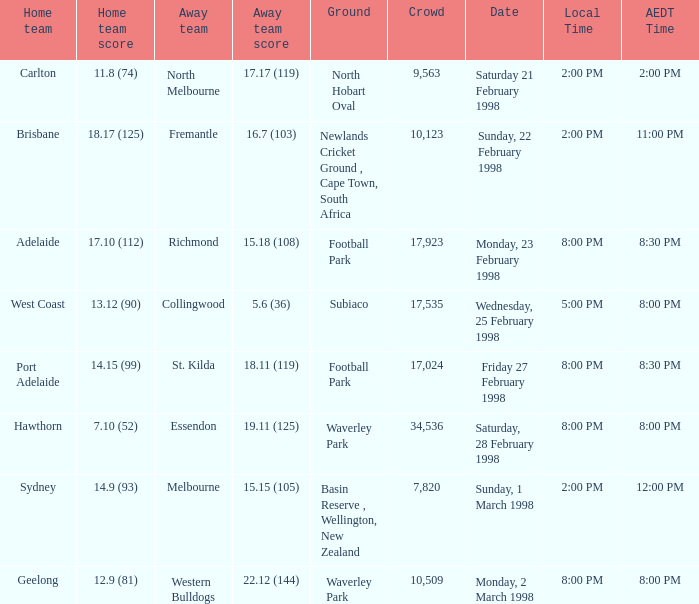12 (144)? 8:00 PM. 